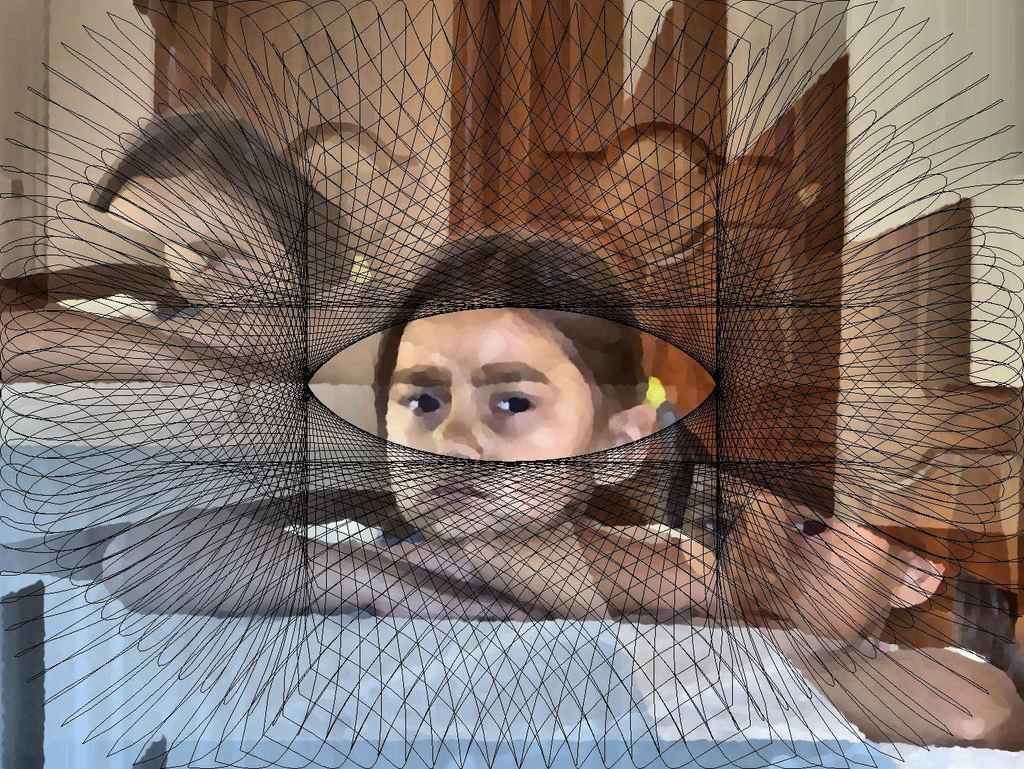Describe this image in one or two sentences. This is an edited image. In the center of the image we can see some persons. In the background of the image we can see the wall and door. 